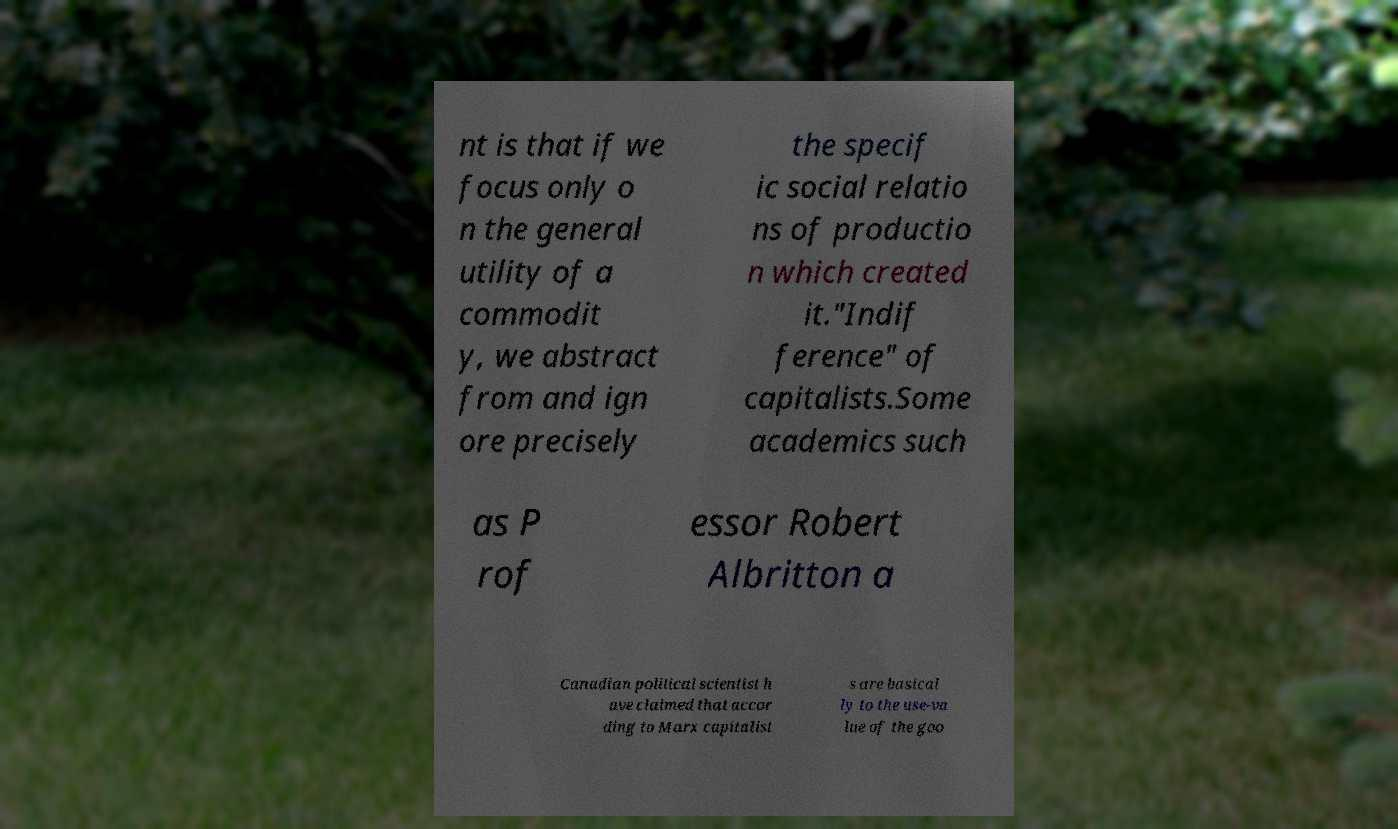Can you read and provide the text displayed in the image?This photo seems to have some interesting text. Can you extract and type it out for me? nt is that if we focus only o n the general utility of a commodit y, we abstract from and ign ore precisely the specif ic social relatio ns of productio n which created it."Indif ference" of capitalists.Some academics such as P rof essor Robert Albritton a Canadian political scientist h ave claimed that accor ding to Marx capitalist s are basical ly to the use-va lue of the goo 